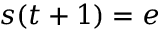<formula> <loc_0><loc_0><loc_500><loc_500>s ( t + 1 ) = e</formula> 